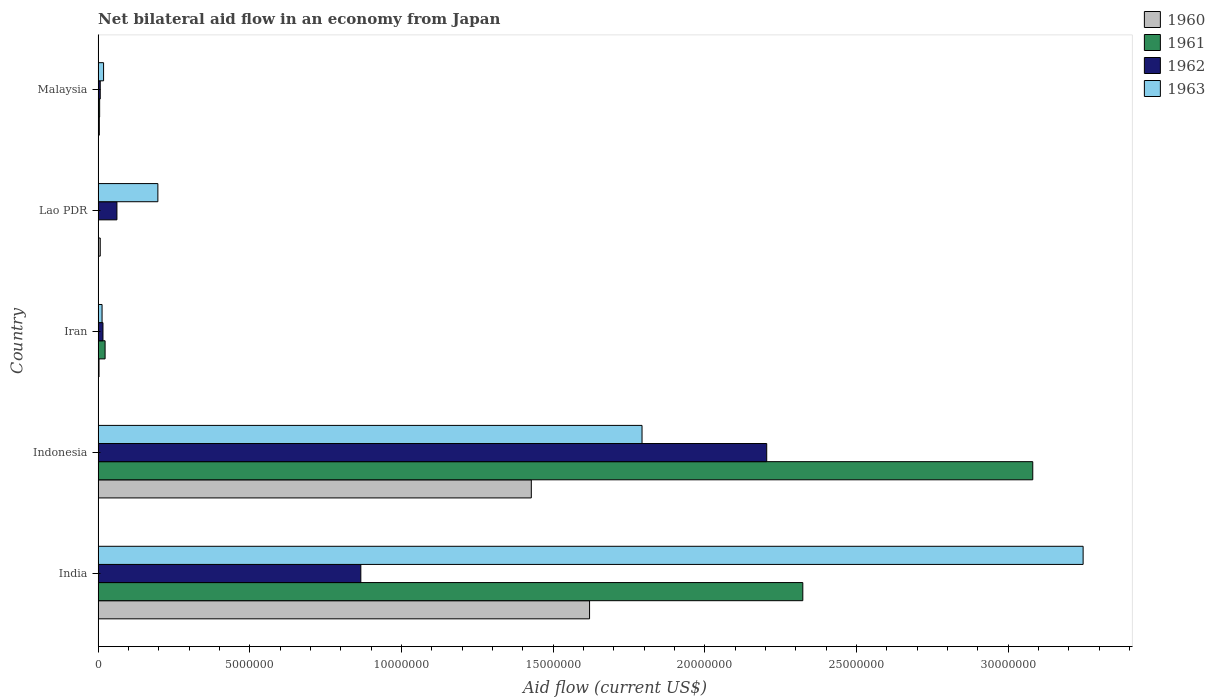How many different coloured bars are there?
Give a very brief answer. 4. How many groups of bars are there?
Keep it short and to the point. 5. Are the number of bars per tick equal to the number of legend labels?
Your response must be concise. Yes. Are the number of bars on each tick of the Y-axis equal?
Your answer should be compact. Yes. How many bars are there on the 2nd tick from the top?
Your response must be concise. 4. What is the label of the 1st group of bars from the top?
Your answer should be compact. Malaysia. What is the net bilateral aid flow in 1961 in Malaysia?
Your answer should be very brief. 5.00e+04. Across all countries, what is the maximum net bilateral aid flow in 1960?
Keep it short and to the point. 1.62e+07. In which country was the net bilateral aid flow in 1962 minimum?
Your response must be concise. Malaysia. What is the total net bilateral aid flow in 1960 in the graph?
Make the answer very short. 3.06e+07. What is the difference between the net bilateral aid flow in 1963 in India and that in Indonesia?
Provide a short and direct response. 1.45e+07. What is the difference between the net bilateral aid flow in 1963 in Lao PDR and the net bilateral aid flow in 1962 in Malaysia?
Offer a very short reply. 1.90e+06. What is the average net bilateral aid flow in 1962 per country?
Make the answer very short. 6.31e+06. What is the difference between the net bilateral aid flow in 1960 and net bilateral aid flow in 1961 in Indonesia?
Provide a short and direct response. -1.65e+07. What is the ratio of the net bilateral aid flow in 1963 in India to that in Iran?
Make the answer very short. 249.77. Is the net bilateral aid flow in 1960 in Iran less than that in Malaysia?
Offer a very short reply. Yes. What is the difference between the highest and the second highest net bilateral aid flow in 1962?
Ensure brevity in your answer.  1.34e+07. What is the difference between the highest and the lowest net bilateral aid flow in 1962?
Keep it short and to the point. 2.20e+07. In how many countries, is the net bilateral aid flow in 1961 greater than the average net bilateral aid flow in 1961 taken over all countries?
Offer a very short reply. 2. What does the 3rd bar from the top in India represents?
Provide a short and direct response. 1961. What does the 2nd bar from the bottom in Indonesia represents?
Offer a terse response. 1961. Is it the case that in every country, the sum of the net bilateral aid flow in 1962 and net bilateral aid flow in 1960 is greater than the net bilateral aid flow in 1961?
Provide a short and direct response. No. How many countries are there in the graph?
Your answer should be compact. 5. Does the graph contain any zero values?
Provide a short and direct response. No. Where does the legend appear in the graph?
Provide a succinct answer. Top right. How many legend labels are there?
Offer a very short reply. 4. What is the title of the graph?
Keep it short and to the point. Net bilateral aid flow in an economy from Japan. What is the label or title of the Y-axis?
Offer a terse response. Country. What is the Aid flow (current US$) in 1960 in India?
Offer a very short reply. 1.62e+07. What is the Aid flow (current US$) in 1961 in India?
Give a very brief answer. 2.32e+07. What is the Aid flow (current US$) of 1962 in India?
Your response must be concise. 8.66e+06. What is the Aid flow (current US$) in 1963 in India?
Your response must be concise. 3.25e+07. What is the Aid flow (current US$) in 1960 in Indonesia?
Make the answer very short. 1.43e+07. What is the Aid flow (current US$) of 1961 in Indonesia?
Your answer should be very brief. 3.08e+07. What is the Aid flow (current US$) in 1962 in Indonesia?
Keep it short and to the point. 2.20e+07. What is the Aid flow (current US$) in 1963 in Indonesia?
Your answer should be compact. 1.79e+07. What is the Aid flow (current US$) in 1960 in Iran?
Offer a terse response. 3.00e+04. What is the Aid flow (current US$) of 1961 in Iran?
Provide a short and direct response. 2.30e+05. What is the Aid flow (current US$) of 1962 in Iran?
Offer a very short reply. 1.60e+05. What is the Aid flow (current US$) in 1960 in Lao PDR?
Offer a terse response. 7.00e+04. What is the Aid flow (current US$) in 1961 in Lao PDR?
Your answer should be compact. 10000. What is the Aid flow (current US$) of 1962 in Lao PDR?
Ensure brevity in your answer.  6.20e+05. What is the Aid flow (current US$) in 1963 in Lao PDR?
Provide a succinct answer. 1.97e+06. What is the Aid flow (current US$) of 1962 in Malaysia?
Provide a short and direct response. 7.00e+04. What is the Aid flow (current US$) in 1963 in Malaysia?
Provide a succinct answer. 1.80e+05. Across all countries, what is the maximum Aid flow (current US$) of 1960?
Offer a very short reply. 1.62e+07. Across all countries, what is the maximum Aid flow (current US$) in 1961?
Make the answer very short. 3.08e+07. Across all countries, what is the maximum Aid flow (current US$) of 1962?
Provide a succinct answer. 2.20e+07. Across all countries, what is the maximum Aid flow (current US$) of 1963?
Provide a succinct answer. 3.25e+07. Across all countries, what is the minimum Aid flow (current US$) of 1960?
Keep it short and to the point. 3.00e+04. Across all countries, what is the minimum Aid flow (current US$) in 1962?
Your answer should be compact. 7.00e+04. What is the total Aid flow (current US$) of 1960 in the graph?
Offer a terse response. 3.06e+07. What is the total Aid flow (current US$) of 1961 in the graph?
Your response must be concise. 5.43e+07. What is the total Aid flow (current US$) of 1962 in the graph?
Offer a terse response. 3.16e+07. What is the total Aid flow (current US$) in 1963 in the graph?
Offer a terse response. 5.27e+07. What is the difference between the Aid flow (current US$) of 1960 in India and that in Indonesia?
Offer a very short reply. 1.92e+06. What is the difference between the Aid flow (current US$) in 1961 in India and that in Indonesia?
Provide a succinct answer. -7.58e+06. What is the difference between the Aid flow (current US$) in 1962 in India and that in Indonesia?
Provide a succinct answer. -1.34e+07. What is the difference between the Aid flow (current US$) in 1963 in India and that in Indonesia?
Ensure brevity in your answer.  1.45e+07. What is the difference between the Aid flow (current US$) of 1960 in India and that in Iran?
Ensure brevity in your answer.  1.62e+07. What is the difference between the Aid flow (current US$) of 1961 in India and that in Iran?
Give a very brief answer. 2.30e+07. What is the difference between the Aid flow (current US$) of 1962 in India and that in Iran?
Your response must be concise. 8.50e+06. What is the difference between the Aid flow (current US$) in 1963 in India and that in Iran?
Your answer should be very brief. 3.23e+07. What is the difference between the Aid flow (current US$) in 1960 in India and that in Lao PDR?
Your answer should be compact. 1.61e+07. What is the difference between the Aid flow (current US$) of 1961 in India and that in Lao PDR?
Provide a succinct answer. 2.32e+07. What is the difference between the Aid flow (current US$) of 1962 in India and that in Lao PDR?
Keep it short and to the point. 8.04e+06. What is the difference between the Aid flow (current US$) of 1963 in India and that in Lao PDR?
Ensure brevity in your answer.  3.05e+07. What is the difference between the Aid flow (current US$) in 1960 in India and that in Malaysia?
Provide a short and direct response. 1.62e+07. What is the difference between the Aid flow (current US$) of 1961 in India and that in Malaysia?
Provide a short and direct response. 2.32e+07. What is the difference between the Aid flow (current US$) in 1962 in India and that in Malaysia?
Offer a terse response. 8.59e+06. What is the difference between the Aid flow (current US$) of 1963 in India and that in Malaysia?
Your answer should be very brief. 3.23e+07. What is the difference between the Aid flow (current US$) in 1960 in Indonesia and that in Iran?
Give a very brief answer. 1.42e+07. What is the difference between the Aid flow (current US$) of 1961 in Indonesia and that in Iran?
Keep it short and to the point. 3.06e+07. What is the difference between the Aid flow (current US$) of 1962 in Indonesia and that in Iran?
Provide a succinct answer. 2.19e+07. What is the difference between the Aid flow (current US$) in 1963 in Indonesia and that in Iran?
Your answer should be very brief. 1.78e+07. What is the difference between the Aid flow (current US$) of 1960 in Indonesia and that in Lao PDR?
Your answer should be compact. 1.42e+07. What is the difference between the Aid flow (current US$) in 1961 in Indonesia and that in Lao PDR?
Offer a very short reply. 3.08e+07. What is the difference between the Aid flow (current US$) in 1962 in Indonesia and that in Lao PDR?
Make the answer very short. 2.14e+07. What is the difference between the Aid flow (current US$) of 1963 in Indonesia and that in Lao PDR?
Keep it short and to the point. 1.60e+07. What is the difference between the Aid flow (current US$) of 1960 in Indonesia and that in Malaysia?
Offer a very short reply. 1.42e+07. What is the difference between the Aid flow (current US$) in 1961 in Indonesia and that in Malaysia?
Offer a very short reply. 3.08e+07. What is the difference between the Aid flow (current US$) in 1962 in Indonesia and that in Malaysia?
Give a very brief answer. 2.20e+07. What is the difference between the Aid flow (current US$) in 1963 in Indonesia and that in Malaysia?
Provide a short and direct response. 1.78e+07. What is the difference between the Aid flow (current US$) of 1962 in Iran and that in Lao PDR?
Your answer should be compact. -4.60e+05. What is the difference between the Aid flow (current US$) of 1963 in Iran and that in Lao PDR?
Offer a terse response. -1.84e+06. What is the difference between the Aid flow (current US$) of 1962 in Iran and that in Malaysia?
Your answer should be very brief. 9.00e+04. What is the difference between the Aid flow (current US$) of 1961 in Lao PDR and that in Malaysia?
Provide a succinct answer. -4.00e+04. What is the difference between the Aid flow (current US$) of 1963 in Lao PDR and that in Malaysia?
Provide a succinct answer. 1.79e+06. What is the difference between the Aid flow (current US$) of 1960 in India and the Aid flow (current US$) of 1961 in Indonesia?
Make the answer very short. -1.46e+07. What is the difference between the Aid flow (current US$) in 1960 in India and the Aid flow (current US$) in 1962 in Indonesia?
Your answer should be very brief. -5.84e+06. What is the difference between the Aid flow (current US$) of 1960 in India and the Aid flow (current US$) of 1963 in Indonesia?
Provide a short and direct response. -1.73e+06. What is the difference between the Aid flow (current US$) in 1961 in India and the Aid flow (current US$) in 1962 in Indonesia?
Give a very brief answer. 1.19e+06. What is the difference between the Aid flow (current US$) in 1961 in India and the Aid flow (current US$) in 1963 in Indonesia?
Your answer should be compact. 5.30e+06. What is the difference between the Aid flow (current US$) in 1962 in India and the Aid flow (current US$) in 1963 in Indonesia?
Your answer should be very brief. -9.27e+06. What is the difference between the Aid flow (current US$) of 1960 in India and the Aid flow (current US$) of 1961 in Iran?
Offer a terse response. 1.60e+07. What is the difference between the Aid flow (current US$) in 1960 in India and the Aid flow (current US$) in 1962 in Iran?
Your answer should be very brief. 1.60e+07. What is the difference between the Aid flow (current US$) of 1960 in India and the Aid flow (current US$) of 1963 in Iran?
Provide a succinct answer. 1.61e+07. What is the difference between the Aid flow (current US$) of 1961 in India and the Aid flow (current US$) of 1962 in Iran?
Offer a very short reply. 2.31e+07. What is the difference between the Aid flow (current US$) in 1961 in India and the Aid flow (current US$) in 1963 in Iran?
Provide a short and direct response. 2.31e+07. What is the difference between the Aid flow (current US$) of 1962 in India and the Aid flow (current US$) of 1963 in Iran?
Offer a terse response. 8.53e+06. What is the difference between the Aid flow (current US$) in 1960 in India and the Aid flow (current US$) in 1961 in Lao PDR?
Give a very brief answer. 1.62e+07. What is the difference between the Aid flow (current US$) of 1960 in India and the Aid flow (current US$) of 1962 in Lao PDR?
Your answer should be compact. 1.56e+07. What is the difference between the Aid flow (current US$) in 1960 in India and the Aid flow (current US$) in 1963 in Lao PDR?
Give a very brief answer. 1.42e+07. What is the difference between the Aid flow (current US$) of 1961 in India and the Aid flow (current US$) of 1962 in Lao PDR?
Ensure brevity in your answer.  2.26e+07. What is the difference between the Aid flow (current US$) in 1961 in India and the Aid flow (current US$) in 1963 in Lao PDR?
Provide a succinct answer. 2.13e+07. What is the difference between the Aid flow (current US$) in 1962 in India and the Aid flow (current US$) in 1963 in Lao PDR?
Give a very brief answer. 6.69e+06. What is the difference between the Aid flow (current US$) in 1960 in India and the Aid flow (current US$) in 1961 in Malaysia?
Provide a succinct answer. 1.62e+07. What is the difference between the Aid flow (current US$) in 1960 in India and the Aid flow (current US$) in 1962 in Malaysia?
Ensure brevity in your answer.  1.61e+07. What is the difference between the Aid flow (current US$) in 1960 in India and the Aid flow (current US$) in 1963 in Malaysia?
Provide a short and direct response. 1.60e+07. What is the difference between the Aid flow (current US$) in 1961 in India and the Aid flow (current US$) in 1962 in Malaysia?
Keep it short and to the point. 2.32e+07. What is the difference between the Aid flow (current US$) of 1961 in India and the Aid flow (current US$) of 1963 in Malaysia?
Keep it short and to the point. 2.30e+07. What is the difference between the Aid flow (current US$) in 1962 in India and the Aid flow (current US$) in 1963 in Malaysia?
Your answer should be compact. 8.48e+06. What is the difference between the Aid flow (current US$) of 1960 in Indonesia and the Aid flow (current US$) of 1961 in Iran?
Make the answer very short. 1.40e+07. What is the difference between the Aid flow (current US$) of 1960 in Indonesia and the Aid flow (current US$) of 1962 in Iran?
Keep it short and to the point. 1.41e+07. What is the difference between the Aid flow (current US$) of 1960 in Indonesia and the Aid flow (current US$) of 1963 in Iran?
Offer a very short reply. 1.42e+07. What is the difference between the Aid flow (current US$) of 1961 in Indonesia and the Aid flow (current US$) of 1962 in Iran?
Offer a terse response. 3.06e+07. What is the difference between the Aid flow (current US$) of 1961 in Indonesia and the Aid flow (current US$) of 1963 in Iran?
Offer a very short reply. 3.07e+07. What is the difference between the Aid flow (current US$) of 1962 in Indonesia and the Aid flow (current US$) of 1963 in Iran?
Offer a terse response. 2.19e+07. What is the difference between the Aid flow (current US$) in 1960 in Indonesia and the Aid flow (current US$) in 1961 in Lao PDR?
Offer a terse response. 1.43e+07. What is the difference between the Aid flow (current US$) of 1960 in Indonesia and the Aid flow (current US$) of 1962 in Lao PDR?
Your answer should be compact. 1.37e+07. What is the difference between the Aid flow (current US$) of 1960 in Indonesia and the Aid flow (current US$) of 1963 in Lao PDR?
Offer a very short reply. 1.23e+07. What is the difference between the Aid flow (current US$) of 1961 in Indonesia and the Aid flow (current US$) of 1962 in Lao PDR?
Make the answer very short. 3.02e+07. What is the difference between the Aid flow (current US$) of 1961 in Indonesia and the Aid flow (current US$) of 1963 in Lao PDR?
Offer a terse response. 2.88e+07. What is the difference between the Aid flow (current US$) of 1962 in Indonesia and the Aid flow (current US$) of 1963 in Lao PDR?
Offer a terse response. 2.01e+07. What is the difference between the Aid flow (current US$) of 1960 in Indonesia and the Aid flow (current US$) of 1961 in Malaysia?
Make the answer very short. 1.42e+07. What is the difference between the Aid flow (current US$) of 1960 in Indonesia and the Aid flow (current US$) of 1962 in Malaysia?
Make the answer very short. 1.42e+07. What is the difference between the Aid flow (current US$) of 1960 in Indonesia and the Aid flow (current US$) of 1963 in Malaysia?
Keep it short and to the point. 1.41e+07. What is the difference between the Aid flow (current US$) in 1961 in Indonesia and the Aid flow (current US$) in 1962 in Malaysia?
Offer a terse response. 3.07e+07. What is the difference between the Aid flow (current US$) in 1961 in Indonesia and the Aid flow (current US$) in 1963 in Malaysia?
Offer a very short reply. 3.06e+07. What is the difference between the Aid flow (current US$) of 1962 in Indonesia and the Aid flow (current US$) of 1963 in Malaysia?
Offer a very short reply. 2.19e+07. What is the difference between the Aid flow (current US$) of 1960 in Iran and the Aid flow (current US$) of 1962 in Lao PDR?
Your response must be concise. -5.90e+05. What is the difference between the Aid flow (current US$) of 1960 in Iran and the Aid flow (current US$) of 1963 in Lao PDR?
Keep it short and to the point. -1.94e+06. What is the difference between the Aid flow (current US$) of 1961 in Iran and the Aid flow (current US$) of 1962 in Lao PDR?
Offer a terse response. -3.90e+05. What is the difference between the Aid flow (current US$) in 1961 in Iran and the Aid flow (current US$) in 1963 in Lao PDR?
Ensure brevity in your answer.  -1.74e+06. What is the difference between the Aid flow (current US$) in 1962 in Iran and the Aid flow (current US$) in 1963 in Lao PDR?
Provide a short and direct response. -1.81e+06. What is the difference between the Aid flow (current US$) of 1960 in Iran and the Aid flow (current US$) of 1963 in Malaysia?
Your answer should be compact. -1.50e+05. What is the difference between the Aid flow (current US$) of 1960 in Lao PDR and the Aid flow (current US$) of 1961 in Malaysia?
Make the answer very short. 2.00e+04. What is the difference between the Aid flow (current US$) in 1960 in Lao PDR and the Aid flow (current US$) in 1962 in Malaysia?
Ensure brevity in your answer.  0. What is the difference between the Aid flow (current US$) in 1961 in Lao PDR and the Aid flow (current US$) in 1962 in Malaysia?
Offer a terse response. -6.00e+04. What is the average Aid flow (current US$) in 1960 per country?
Give a very brief answer. 6.12e+06. What is the average Aid flow (current US$) in 1961 per country?
Your answer should be compact. 1.09e+07. What is the average Aid flow (current US$) in 1962 per country?
Your response must be concise. 6.31e+06. What is the average Aid flow (current US$) in 1963 per country?
Provide a short and direct response. 1.05e+07. What is the difference between the Aid flow (current US$) of 1960 and Aid flow (current US$) of 1961 in India?
Offer a terse response. -7.03e+06. What is the difference between the Aid flow (current US$) in 1960 and Aid flow (current US$) in 1962 in India?
Your response must be concise. 7.54e+06. What is the difference between the Aid flow (current US$) of 1960 and Aid flow (current US$) of 1963 in India?
Offer a terse response. -1.63e+07. What is the difference between the Aid flow (current US$) of 1961 and Aid flow (current US$) of 1962 in India?
Your answer should be very brief. 1.46e+07. What is the difference between the Aid flow (current US$) in 1961 and Aid flow (current US$) in 1963 in India?
Keep it short and to the point. -9.24e+06. What is the difference between the Aid flow (current US$) of 1962 and Aid flow (current US$) of 1963 in India?
Ensure brevity in your answer.  -2.38e+07. What is the difference between the Aid flow (current US$) of 1960 and Aid flow (current US$) of 1961 in Indonesia?
Provide a short and direct response. -1.65e+07. What is the difference between the Aid flow (current US$) of 1960 and Aid flow (current US$) of 1962 in Indonesia?
Your response must be concise. -7.76e+06. What is the difference between the Aid flow (current US$) of 1960 and Aid flow (current US$) of 1963 in Indonesia?
Offer a very short reply. -3.65e+06. What is the difference between the Aid flow (current US$) of 1961 and Aid flow (current US$) of 1962 in Indonesia?
Make the answer very short. 8.77e+06. What is the difference between the Aid flow (current US$) of 1961 and Aid flow (current US$) of 1963 in Indonesia?
Keep it short and to the point. 1.29e+07. What is the difference between the Aid flow (current US$) in 1962 and Aid flow (current US$) in 1963 in Indonesia?
Offer a terse response. 4.11e+06. What is the difference between the Aid flow (current US$) in 1960 and Aid flow (current US$) in 1963 in Iran?
Make the answer very short. -1.00e+05. What is the difference between the Aid flow (current US$) of 1961 and Aid flow (current US$) of 1962 in Iran?
Give a very brief answer. 7.00e+04. What is the difference between the Aid flow (current US$) of 1961 and Aid flow (current US$) of 1963 in Iran?
Keep it short and to the point. 1.00e+05. What is the difference between the Aid flow (current US$) of 1960 and Aid flow (current US$) of 1962 in Lao PDR?
Offer a terse response. -5.50e+05. What is the difference between the Aid flow (current US$) in 1960 and Aid flow (current US$) in 1963 in Lao PDR?
Your answer should be very brief. -1.90e+06. What is the difference between the Aid flow (current US$) of 1961 and Aid flow (current US$) of 1962 in Lao PDR?
Provide a succinct answer. -6.10e+05. What is the difference between the Aid flow (current US$) in 1961 and Aid flow (current US$) in 1963 in Lao PDR?
Ensure brevity in your answer.  -1.96e+06. What is the difference between the Aid flow (current US$) of 1962 and Aid flow (current US$) of 1963 in Lao PDR?
Give a very brief answer. -1.35e+06. What is the difference between the Aid flow (current US$) in 1962 and Aid flow (current US$) in 1963 in Malaysia?
Keep it short and to the point. -1.10e+05. What is the ratio of the Aid flow (current US$) in 1960 in India to that in Indonesia?
Offer a very short reply. 1.13. What is the ratio of the Aid flow (current US$) in 1961 in India to that in Indonesia?
Keep it short and to the point. 0.75. What is the ratio of the Aid flow (current US$) in 1962 in India to that in Indonesia?
Provide a succinct answer. 0.39. What is the ratio of the Aid flow (current US$) of 1963 in India to that in Indonesia?
Offer a very short reply. 1.81. What is the ratio of the Aid flow (current US$) in 1960 in India to that in Iran?
Your answer should be very brief. 540. What is the ratio of the Aid flow (current US$) of 1961 in India to that in Iran?
Give a very brief answer. 101. What is the ratio of the Aid flow (current US$) of 1962 in India to that in Iran?
Your response must be concise. 54.12. What is the ratio of the Aid flow (current US$) of 1963 in India to that in Iran?
Ensure brevity in your answer.  249.77. What is the ratio of the Aid flow (current US$) of 1960 in India to that in Lao PDR?
Your answer should be very brief. 231.43. What is the ratio of the Aid flow (current US$) in 1961 in India to that in Lao PDR?
Offer a very short reply. 2323. What is the ratio of the Aid flow (current US$) in 1962 in India to that in Lao PDR?
Your response must be concise. 13.97. What is the ratio of the Aid flow (current US$) in 1963 in India to that in Lao PDR?
Your answer should be compact. 16.48. What is the ratio of the Aid flow (current US$) of 1960 in India to that in Malaysia?
Keep it short and to the point. 405. What is the ratio of the Aid flow (current US$) in 1961 in India to that in Malaysia?
Your response must be concise. 464.6. What is the ratio of the Aid flow (current US$) of 1962 in India to that in Malaysia?
Keep it short and to the point. 123.71. What is the ratio of the Aid flow (current US$) in 1963 in India to that in Malaysia?
Provide a succinct answer. 180.39. What is the ratio of the Aid flow (current US$) of 1960 in Indonesia to that in Iran?
Provide a short and direct response. 476. What is the ratio of the Aid flow (current US$) of 1961 in Indonesia to that in Iran?
Offer a terse response. 133.96. What is the ratio of the Aid flow (current US$) of 1962 in Indonesia to that in Iran?
Ensure brevity in your answer.  137.75. What is the ratio of the Aid flow (current US$) in 1963 in Indonesia to that in Iran?
Provide a succinct answer. 137.92. What is the ratio of the Aid flow (current US$) in 1960 in Indonesia to that in Lao PDR?
Ensure brevity in your answer.  204. What is the ratio of the Aid flow (current US$) of 1961 in Indonesia to that in Lao PDR?
Your answer should be very brief. 3081. What is the ratio of the Aid flow (current US$) in 1962 in Indonesia to that in Lao PDR?
Make the answer very short. 35.55. What is the ratio of the Aid flow (current US$) in 1963 in Indonesia to that in Lao PDR?
Your answer should be very brief. 9.1. What is the ratio of the Aid flow (current US$) in 1960 in Indonesia to that in Malaysia?
Keep it short and to the point. 357. What is the ratio of the Aid flow (current US$) of 1961 in Indonesia to that in Malaysia?
Offer a very short reply. 616.2. What is the ratio of the Aid flow (current US$) in 1962 in Indonesia to that in Malaysia?
Your answer should be compact. 314.86. What is the ratio of the Aid flow (current US$) in 1963 in Indonesia to that in Malaysia?
Keep it short and to the point. 99.61. What is the ratio of the Aid flow (current US$) in 1960 in Iran to that in Lao PDR?
Provide a short and direct response. 0.43. What is the ratio of the Aid flow (current US$) of 1961 in Iran to that in Lao PDR?
Ensure brevity in your answer.  23. What is the ratio of the Aid flow (current US$) of 1962 in Iran to that in Lao PDR?
Provide a succinct answer. 0.26. What is the ratio of the Aid flow (current US$) of 1963 in Iran to that in Lao PDR?
Provide a succinct answer. 0.07. What is the ratio of the Aid flow (current US$) of 1961 in Iran to that in Malaysia?
Ensure brevity in your answer.  4.6. What is the ratio of the Aid flow (current US$) in 1962 in Iran to that in Malaysia?
Keep it short and to the point. 2.29. What is the ratio of the Aid flow (current US$) in 1963 in Iran to that in Malaysia?
Your response must be concise. 0.72. What is the ratio of the Aid flow (current US$) of 1962 in Lao PDR to that in Malaysia?
Make the answer very short. 8.86. What is the ratio of the Aid flow (current US$) in 1963 in Lao PDR to that in Malaysia?
Give a very brief answer. 10.94. What is the difference between the highest and the second highest Aid flow (current US$) in 1960?
Keep it short and to the point. 1.92e+06. What is the difference between the highest and the second highest Aid flow (current US$) of 1961?
Ensure brevity in your answer.  7.58e+06. What is the difference between the highest and the second highest Aid flow (current US$) in 1962?
Ensure brevity in your answer.  1.34e+07. What is the difference between the highest and the second highest Aid flow (current US$) in 1963?
Offer a terse response. 1.45e+07. What is the difference between the highest and the lowest Aid flow (current US$) of 1960?
Your answer should be very brief. 1.62e+07. What is the difference between the highest and the lowest Aid flow (current US$) in 1961?
Provide a succinct answer. 3.08e+07. What is the difference between the highest and the lowest Aid flow (current US$) of 1962?
Keep it short and to the point. 2.20e+07. What is the difference between the highest and the lowest Aid flow (current US$) of 1963?
Ensure brevity in your answer.  3.23e+07. 